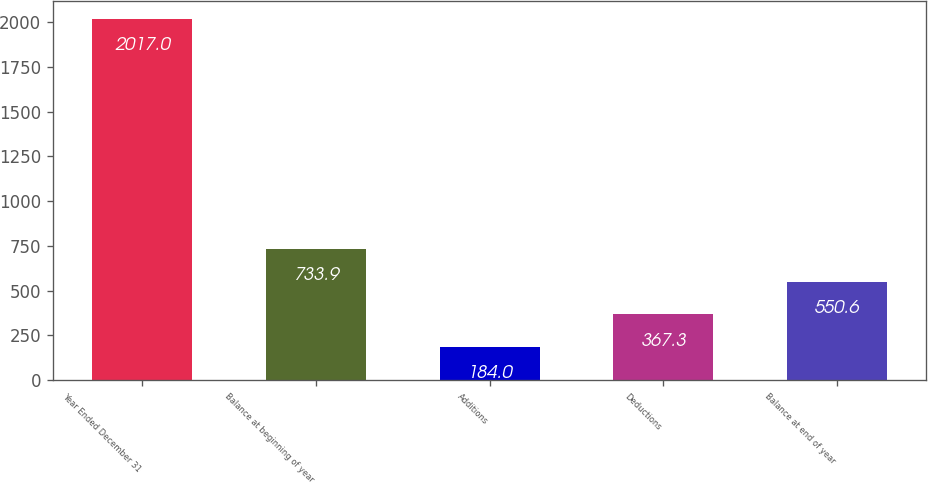Convert chart. <chart><loc_0><loc_0><loc_500><loc_500><bar_chart><fcel>Year Ended December 31<fcel>Balance at beginning of year<fcel>Additions<fcel>Deductions<fcel>Balance at end of year<nl><fcel>2017<fcel>733.9<fcel>184<fcel>367.3<fcel>550.6<nl></chart> 